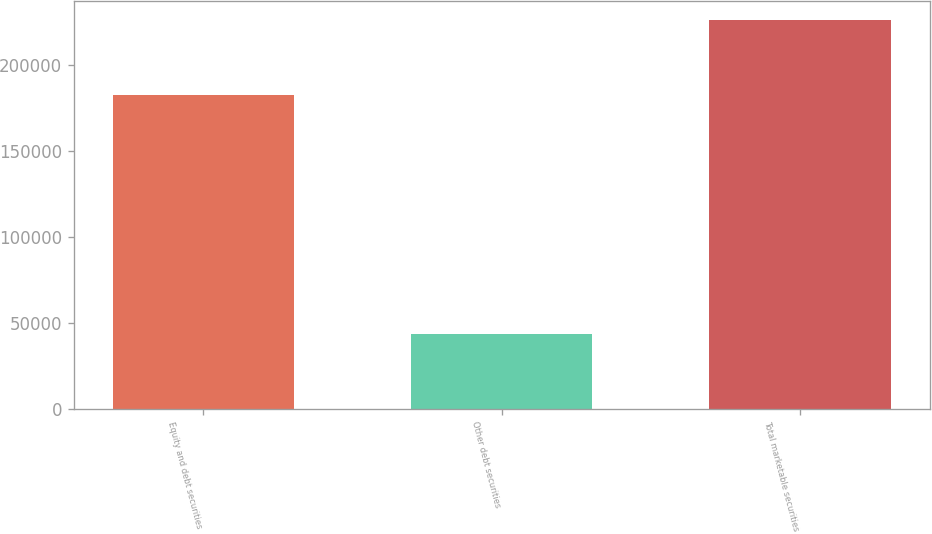<chart> <loc_0><loc_0><loc_500><loc_500><bar_chart><fcel>Equity and debt securities<fcel>Other debt securities<fcel>Total marketable securities<nl><fcel>182826<fcel>43500<fcel>226326<nl></chart> 